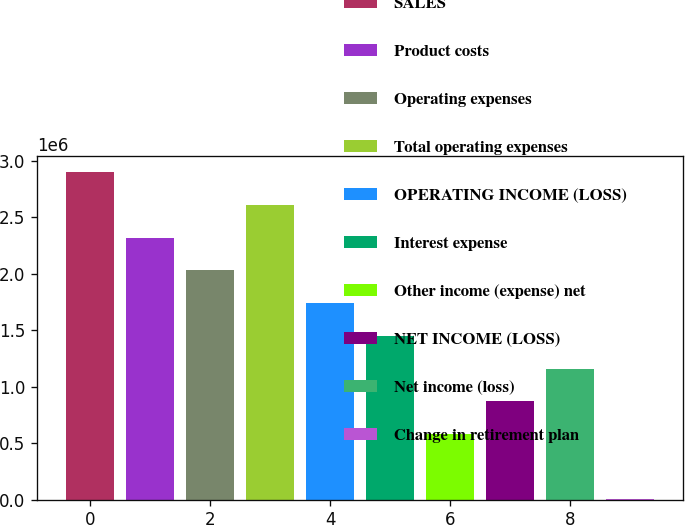Convert chart. <chart><loc_0><loc_0><loc_500><loc_500><bar_chart><fcel>SALES<fcel>Product costs<fcel>Operating expenses<fcel>Total operating expenses<fcel>OPERATING INCOME (LOSS)<fcel>Interest expense<fcel>Other income (expense) net<fcel>NET INCOME (LOSS)<fcel>Net income (loss)<fcel>Change in retirement plan<nl><fcel>2.89823e+06<fcel>2.3191e+06<fcel>2.02954e+06<fcel>2.60867e+06<fcel>1.73997e+06<fcel>1.45041e+06<fcel>581718<fcel>871282<fcel>1.16085e+06<fcel>2589<nl></chart> 